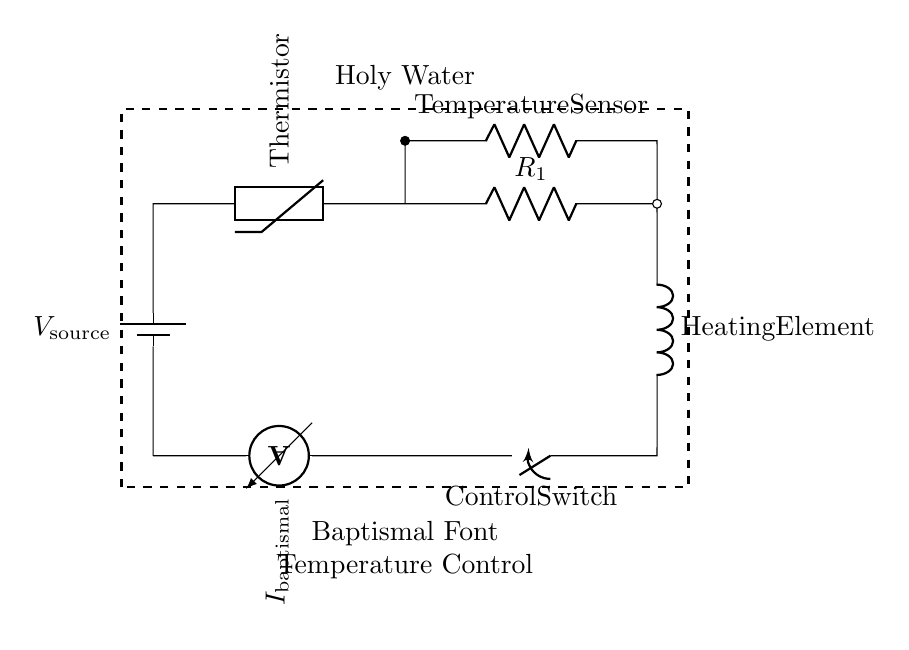What is the component labeled as "Thermistor"? The component is a thermistor, which is a type of resistor whose resistance varies significantly with temperature. Its role is to detect temperature changes in the circuit.
Answer: Thermistor What does the control switch do in this circuit? The control switch regulates the flow of current to the heating element by opening or closing the circuit, allowing the user to turn the heating on or off.
Answer: Control Switch What is the purpose of the ammeter in this circuit? The ammeter measures the current flowing through the circuit, providing information about the heating element's operation and ensuring the system runs efficiently.
Answer: Ammeter What is the relationship between the thermistor and the temperature sensor? The thermistor serves as the temperature sensor, as both components are involved in measuring and responding to changes in temperature for effective heating control.
Answer: Same How is the heating element powered in this circuit? The heating element is powered through the battery, which supplies voltage to the circuit. When current flows due to the closed control switch, the heating element operates.
Answer: Battery Which components form the series circuit in this diagram? The components in the series circuit include the battery, thermistor, resistance (R1), heating element, and control switch, all connected in a single path for current to flow.
Answer: Battery, Thermistor, R1, Heating Element, Control Switch 